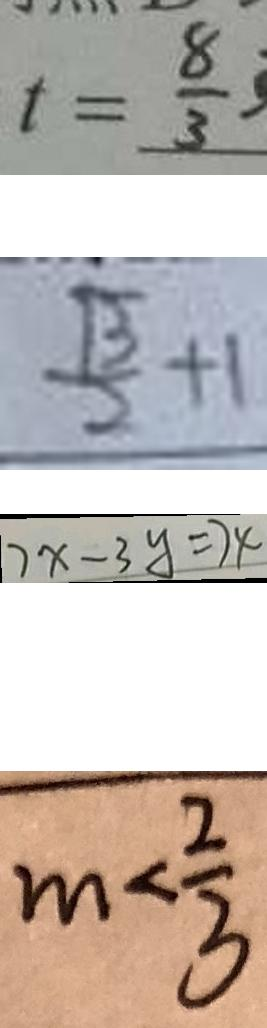<formula> <loc_0><loc_0><loc_500><loc_500>t = \frac { 8 } { 3 } 
 \frac { \sqrt { 3 } } { 2 } + 1 
 7 x - 3 y = 7 4 
 m < \frac { 2 } { 3 }</formula> 